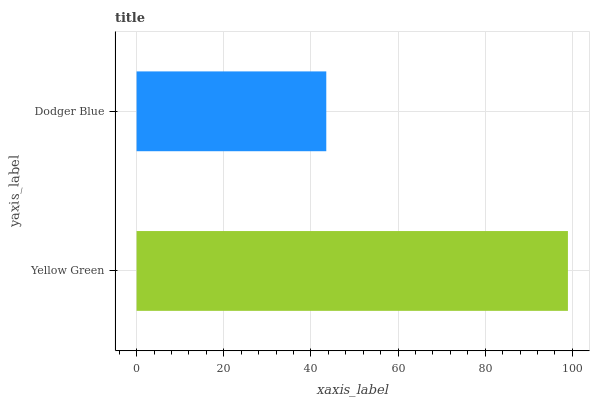Is Dodger Blue the minimum?
Answer yes or no. Yes. Is Yellow Green the maximum?
Answer yes or no. Yes. Is Dodger Blue the maximum?
Answer yes or no. No. Is Yellow Green greater than Dodger Blue?
Answer yes or no. Yes. Is Dodger Blue less than Yellow Green?
Answer yes or no. Yes. Is Dodger Blue greater than Yellow Green?
Answer yes or no. No. Is Yellow Green less than Dodger Blue?
Answer yes or no. No. Is Yellow Green the high median?
Answer yes or no. Yes. Is Dodger Blue the low median?
Answer yes or no. Yes. Is Dodger Blue the high median?
Answer yes or no. No. Is Yellow Green the low median?
Answer yes or no. No. 